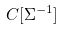<formula> <loc_0><loc_0><loc_500><loc_500>C [ \Sigma ^ { - 1 } ]</formula> 